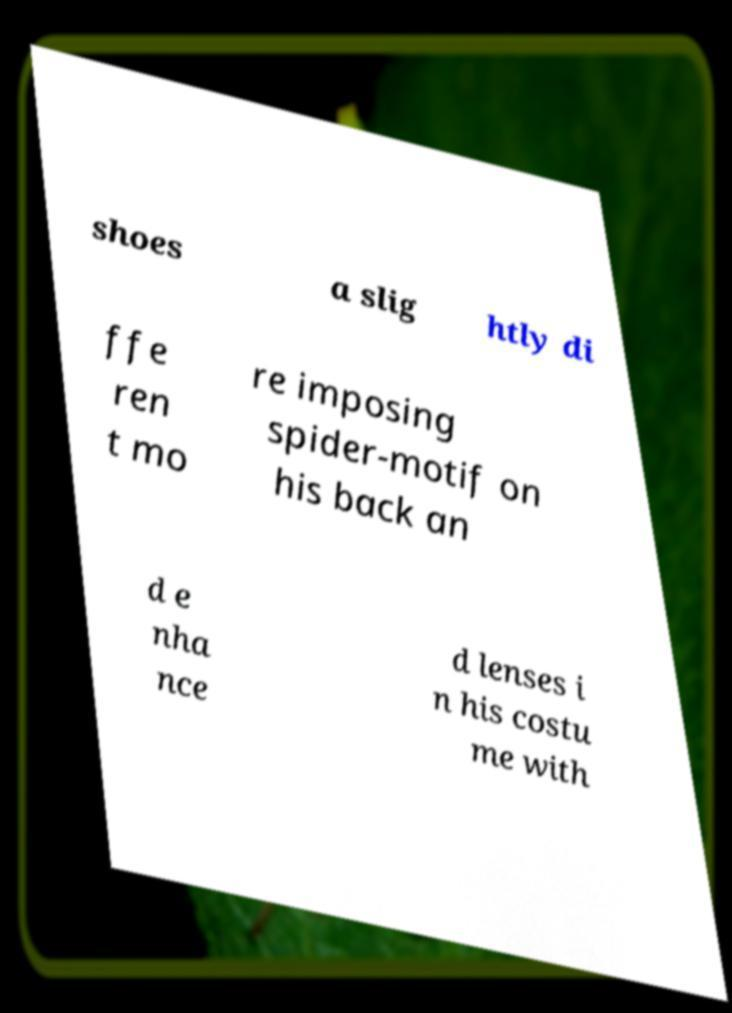I need the written content from this picture converted into text. Can you do that? shoes a slig htly di ffe ren t mo re imposing spider-motif on his back an d e nha nce d lenses i n his costu me with 